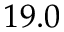Convert formula to latex. <formula><loc_0><loc_0><loc_500><loc_500>1 9 . 0</formula> 